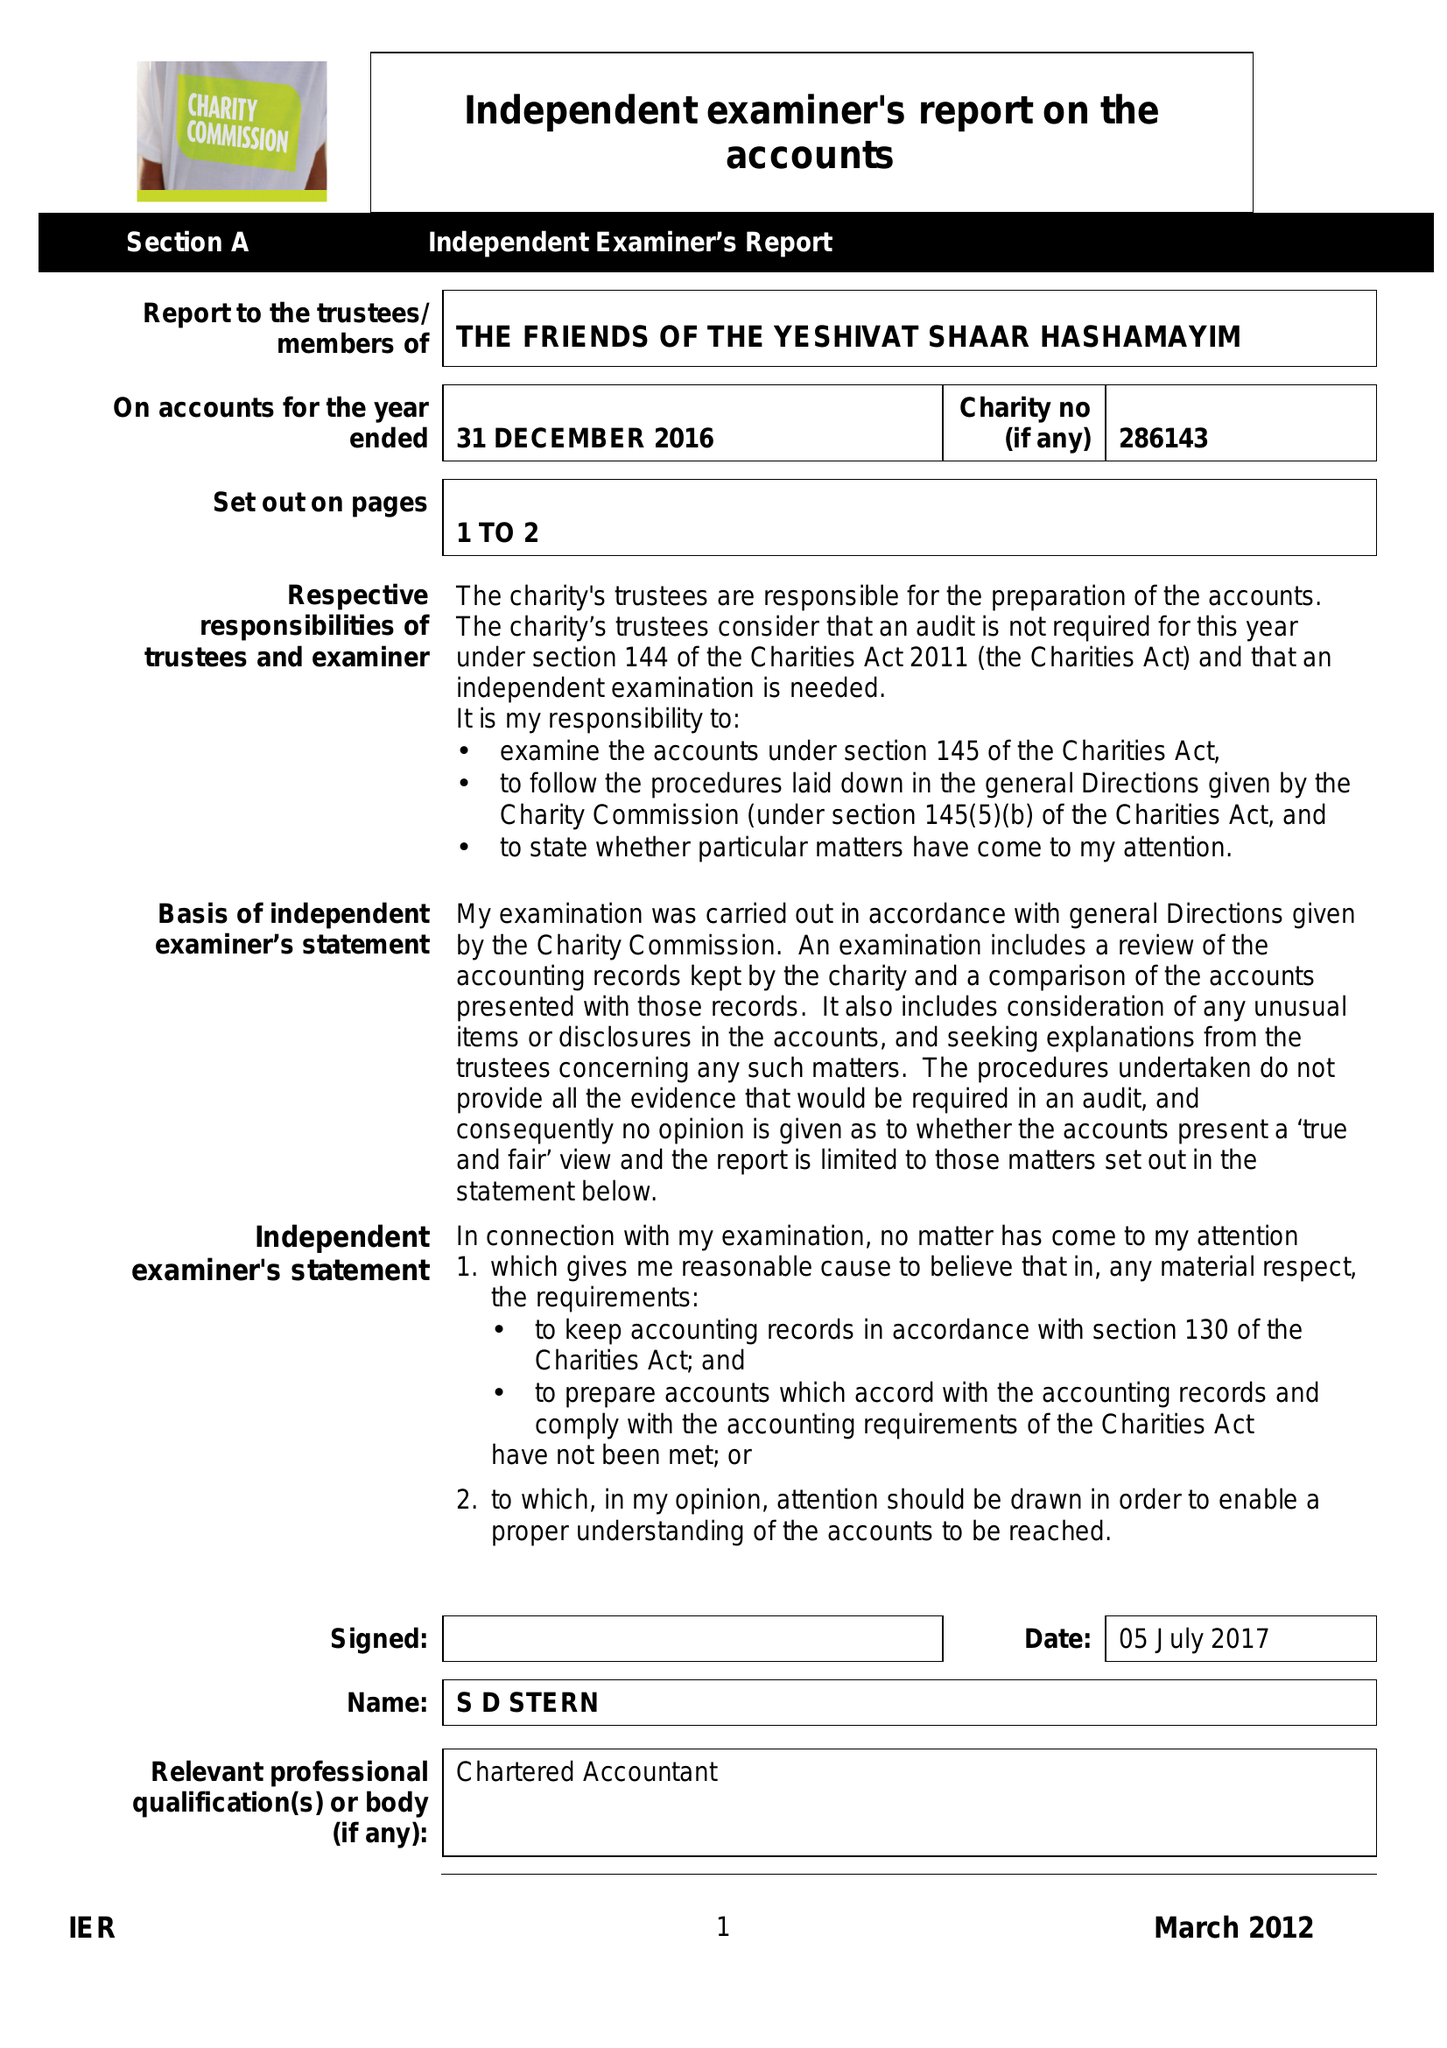What is the value for the income_annually_in_british_pounds?
Answer the question using a single word or phrase. 51434.00 